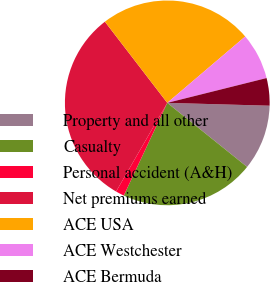Convert chart. <chart><loc_0><loc_0><loc_500><loc_500><pie_chart><fcel>Property and all other<fcel>Casualty<fcel>Personal accident (A&H)<fcel>Net premiums earned<fcel>ACE USA<fcel>ACE Westchester<fcel>ACE Bermuda<nl><fcel>10.32%<fcel>21.22%<fcel>1.35%<fcel>31.24%<fcel>24.2%<fcel>7.33%<fcel>4.34%<nl></chart> 